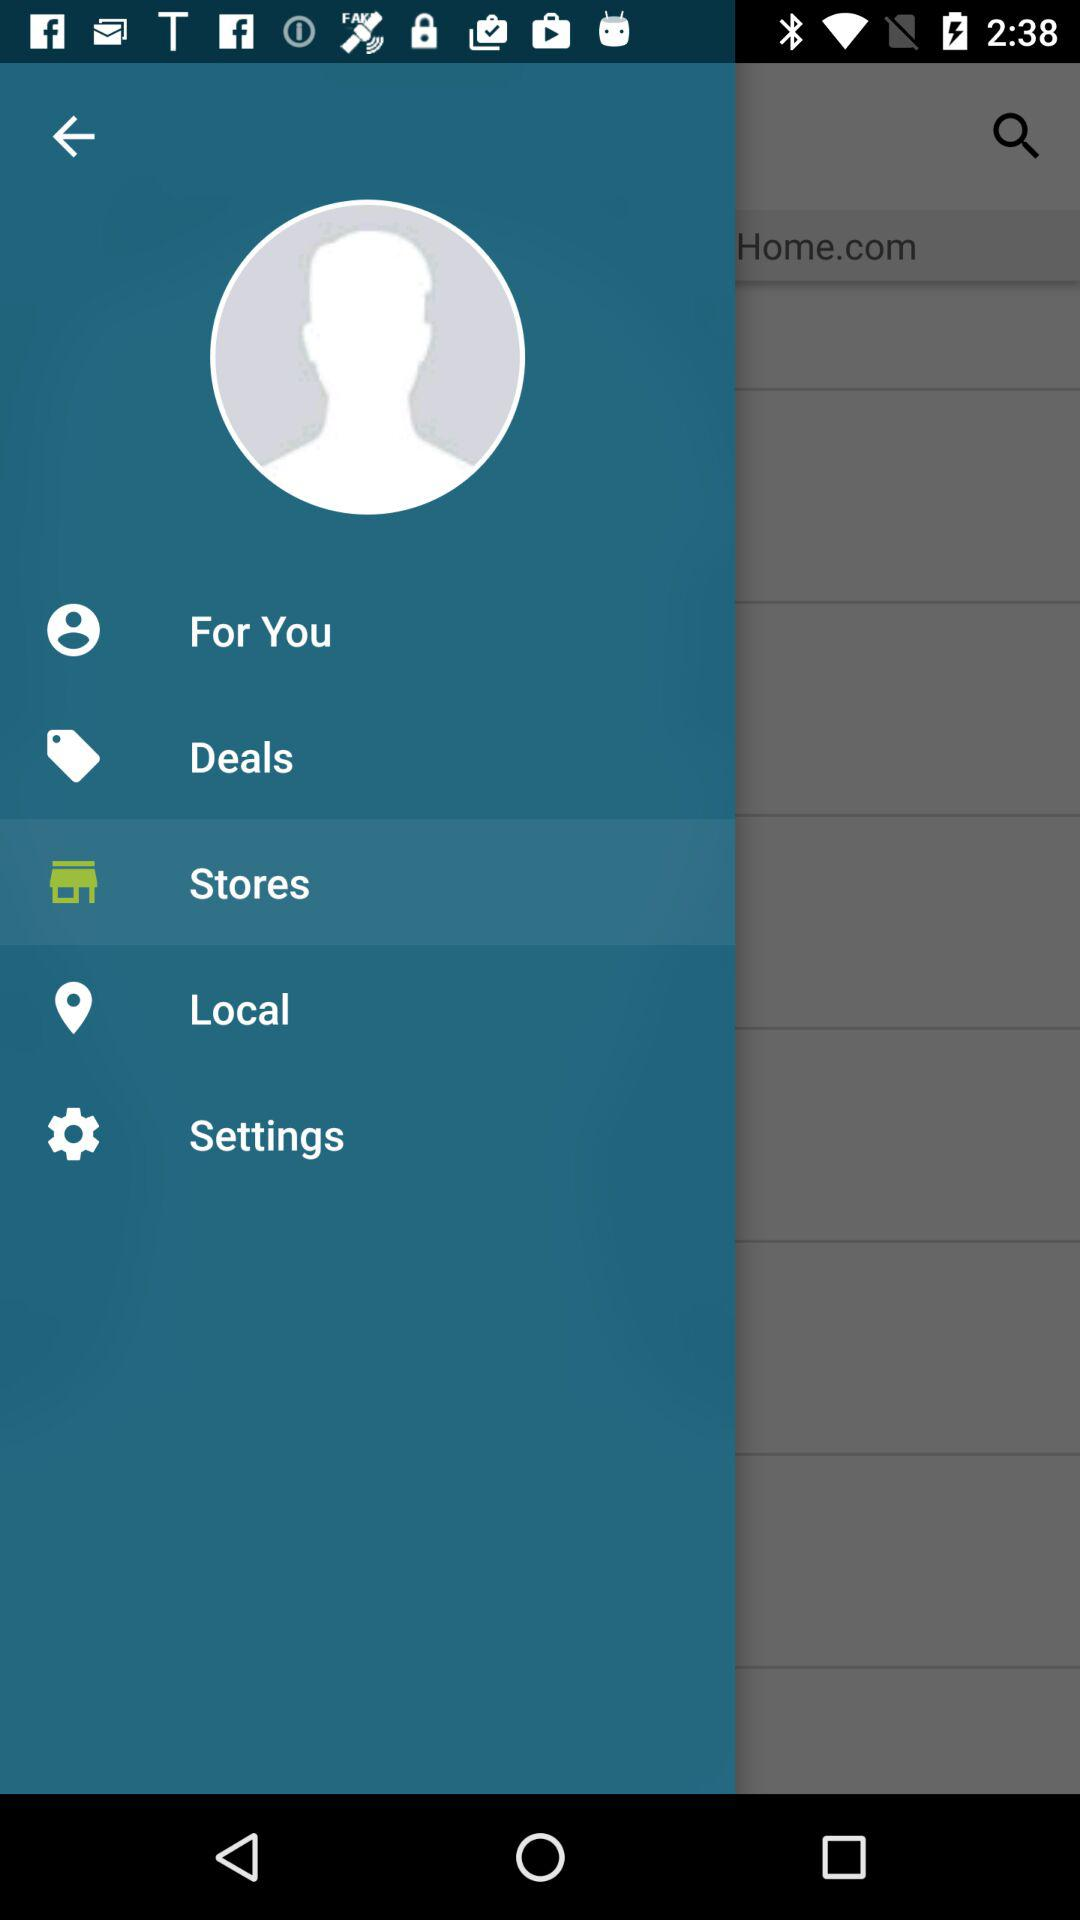Which option is currently selected? The selected option is "Stores". 